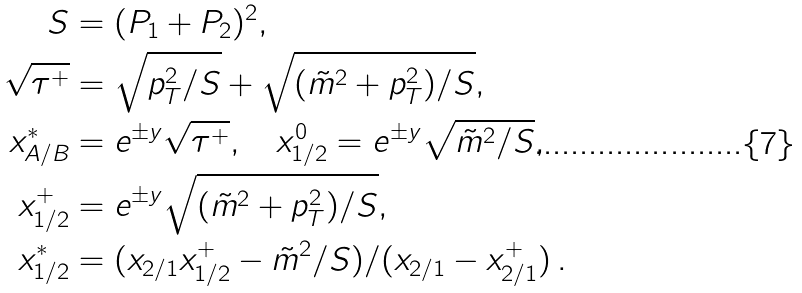<formula> <loc_0><loc_0><loc_500><loc_500>S & = ( P _ { 1 } + P _ { 2 } ) ^ { 2 } , \\ \sqrt { \tau ^ { + } } & = \sqrt { p _ { T } ^ { 2 } / S } + \sqrt { ( \tilde { m } ^ { 2 } + p _ { T } ^ { 2 } ) / S } , \\ x _ { A / B } ^ { * } & = e ^ { \pm y } \sqrt { \tau ^ { + } } , \quad x _ { 1 / 2 } ^ { 0 } = e ^ { \pm y } \sqrt { \tilde { m } ^ { 2 } / S } , \\ x _ { 1 / 2 } ^ { + } & = e ^ { \pm y } \sqrt { ( \tilde { m } ^ { 2 } + p _ { T } ^ { 2 } ) / S } , \\ x _ { 1 / 2 } ^ { * } & = ( x _ { 2 / 1 } x _ { 1 / 2 } ^ { + } - \tilde { m } ^ { 2 } / S ) / ( x _ { 2 / 1 } - x _ { 2 / 1 } ^ { + } ) \, .</formula> 